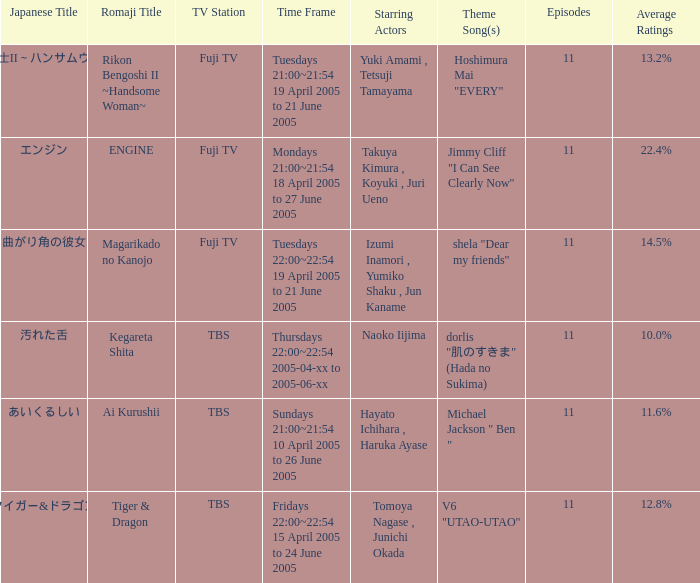What is the japanese title with an average score of 1 あいくるしい. 